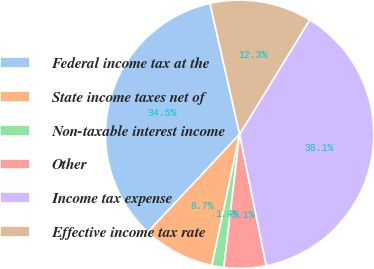Convert chart to OTSL. <chart><loc_0><loc_0><loc_500><loc_500><pie_chart><fcel>Federal income tax at the<fcel>State income taxes net of<fcel>Non-taxable interest income<fcel>Other<fcel>Income tax expense<fcel>Effective income tax rate<nl><fcel>34.45%<fcel>8.68%<fcel>1.44%<fcel>5.06%<fcel>38.07%<fcel>12.3%<nl></chart> 